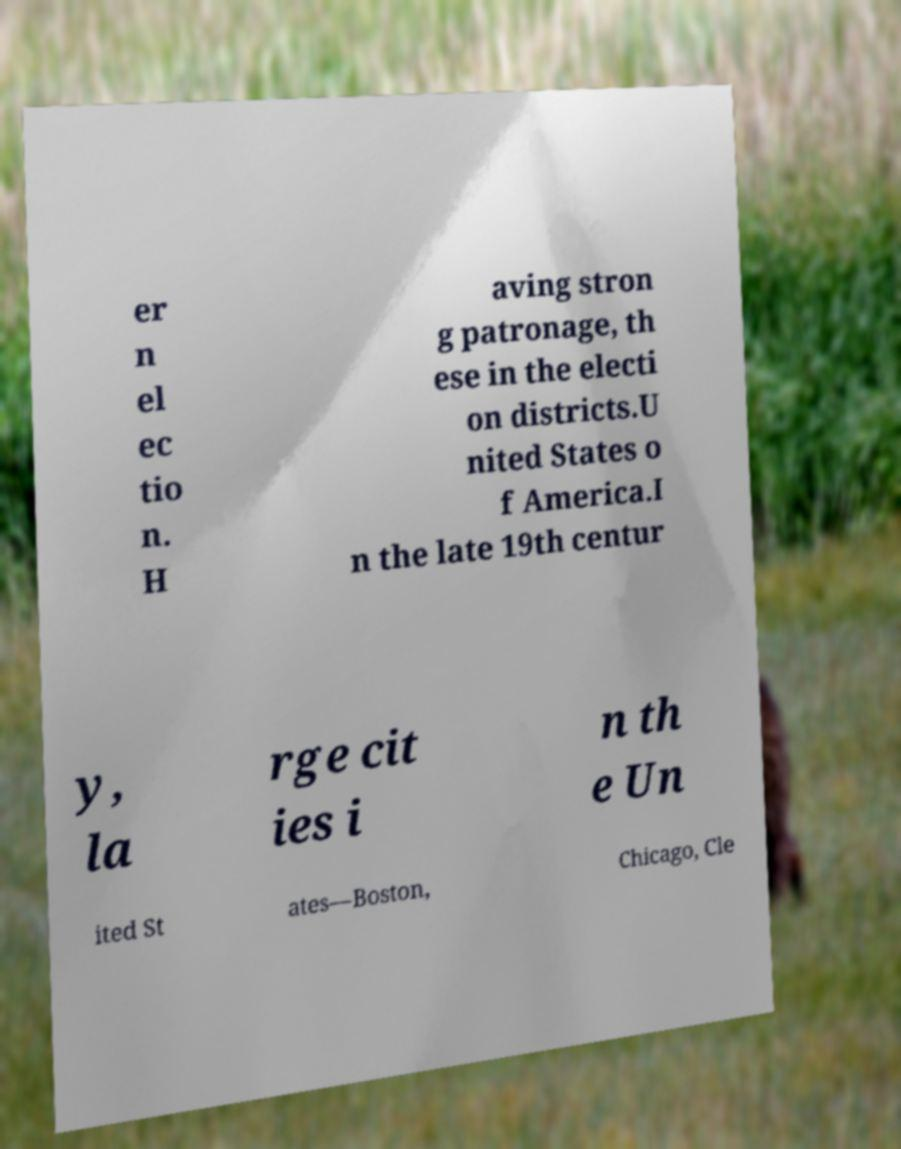Can you read and provide the text displayed in the image?This photo seems to have some interesting text. Can you extract and type it out for me? er n el ec tio n. H aving stron g patronage, th ese in the electi on districts.U nited States o f America.I n the late 19th centur y, la rge cit ies i n th e Un ited St ates—Boston, Chicago, Cle 